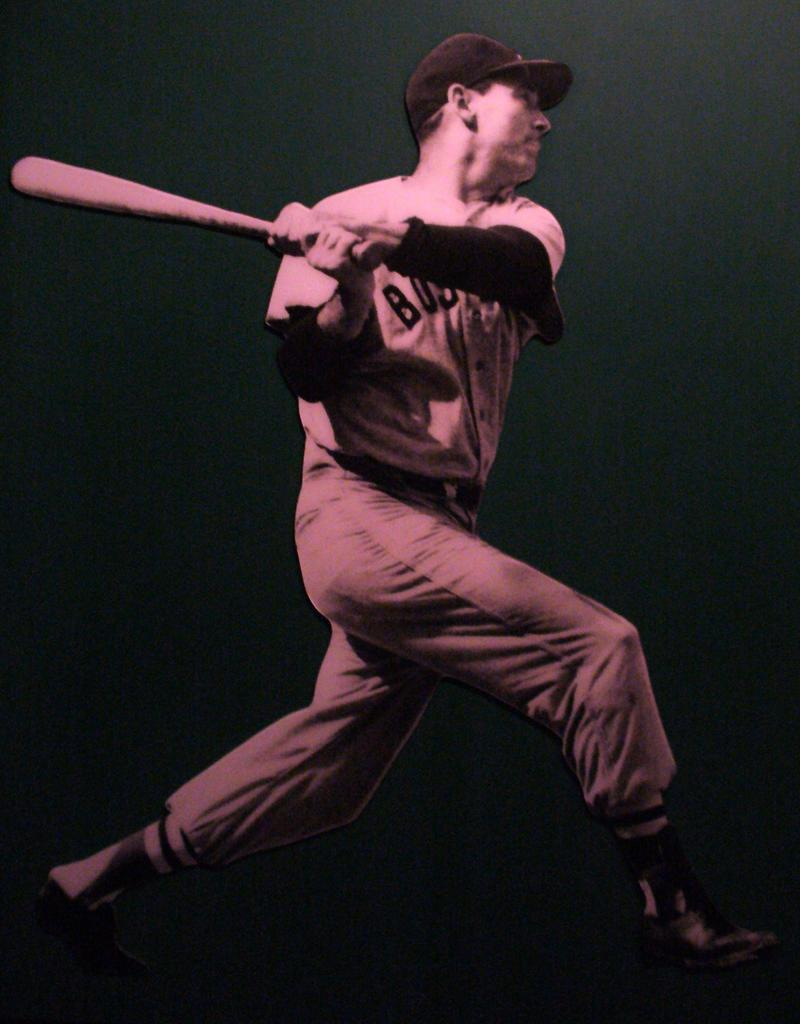What is the main subject of the image? The main subject of the image is a man. What is the man wearing on his head? The man is wearing a cap. What object is the man holding in the image? The man is holding a baseball bat. What type of ocean can be seen in the background of the image? There is no ocean visible in the image; it features a man wearing a cap and holding a baseball bat. What is the man telling a joke about in the image? There is no indication in the image that the man is telling a joke or discussing the moon. 